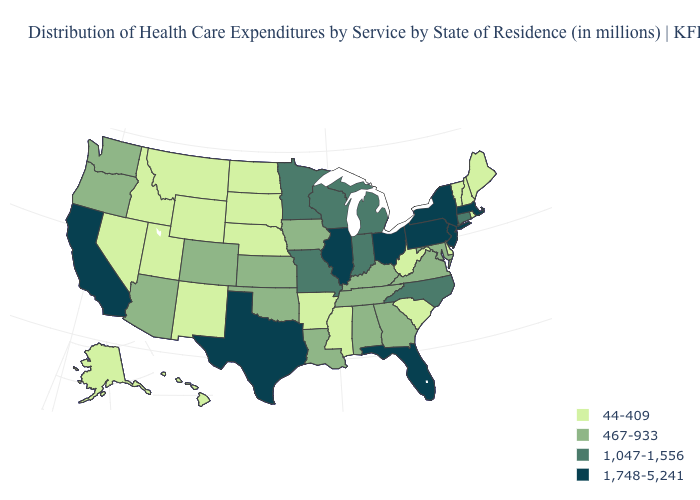Does Ohio have a lower value than Washington?
Be succinct. No. How many symbols are there in the legend?
Answer briefly. 4. What is the value of Kansas?
Short answer required. 467-933. What is the highest value in the South ?
Answer briefly. 1,748-5,241. Name the states that have a value in the range 1,748-5,241?
Answer briefly. California, Florida, Illinois, Massachusetts, New Jersey, New York, Ohio, Pennsylvania, Texas. Among the states that border North Carolina , does Tennessee have the lowest value?
Answer briefly. No. What is the highest value in the USA?
Give a very brief answer. 1,748-5,241. What is the value of Arizona?
Answer briefly. 467-933. Name the states that have a value in the range 467-933?
Concise answer only. Alabama, Arizona, Colorado, Georgia, Iowa, Kansas, Kentucky, Louisiana, Maryland, Oklahoma, Oregon, Tennessee, Virginia, Washington. What is the lowest value in the USA?
Concise answer only. 44-409. Does Colorado have a higher value than Hawaii?
Quick response, please. Yes. What is the highest value in states that border New Hampshire?
Concise answer only. 1,748-5,241. Name the states that have a value in the range 1,748-5,241?
Answer briefly. California, Florida, Illinois, Massachusetts, New Jersey, New York, Ohio, Pennsylvania, Texas. Does North Dakota have the same value as West Virginia?
Concise answer only. Yes. Name the states that have a value in the range 467-933?
Give a very brief answer. Alabama, Arizona, Colorado, Georgia, Iowa, Kansas, Kentucky, Louisiana, Maryland, Oklahoma, Oregon, Tennessee, Virginia, Washington. 